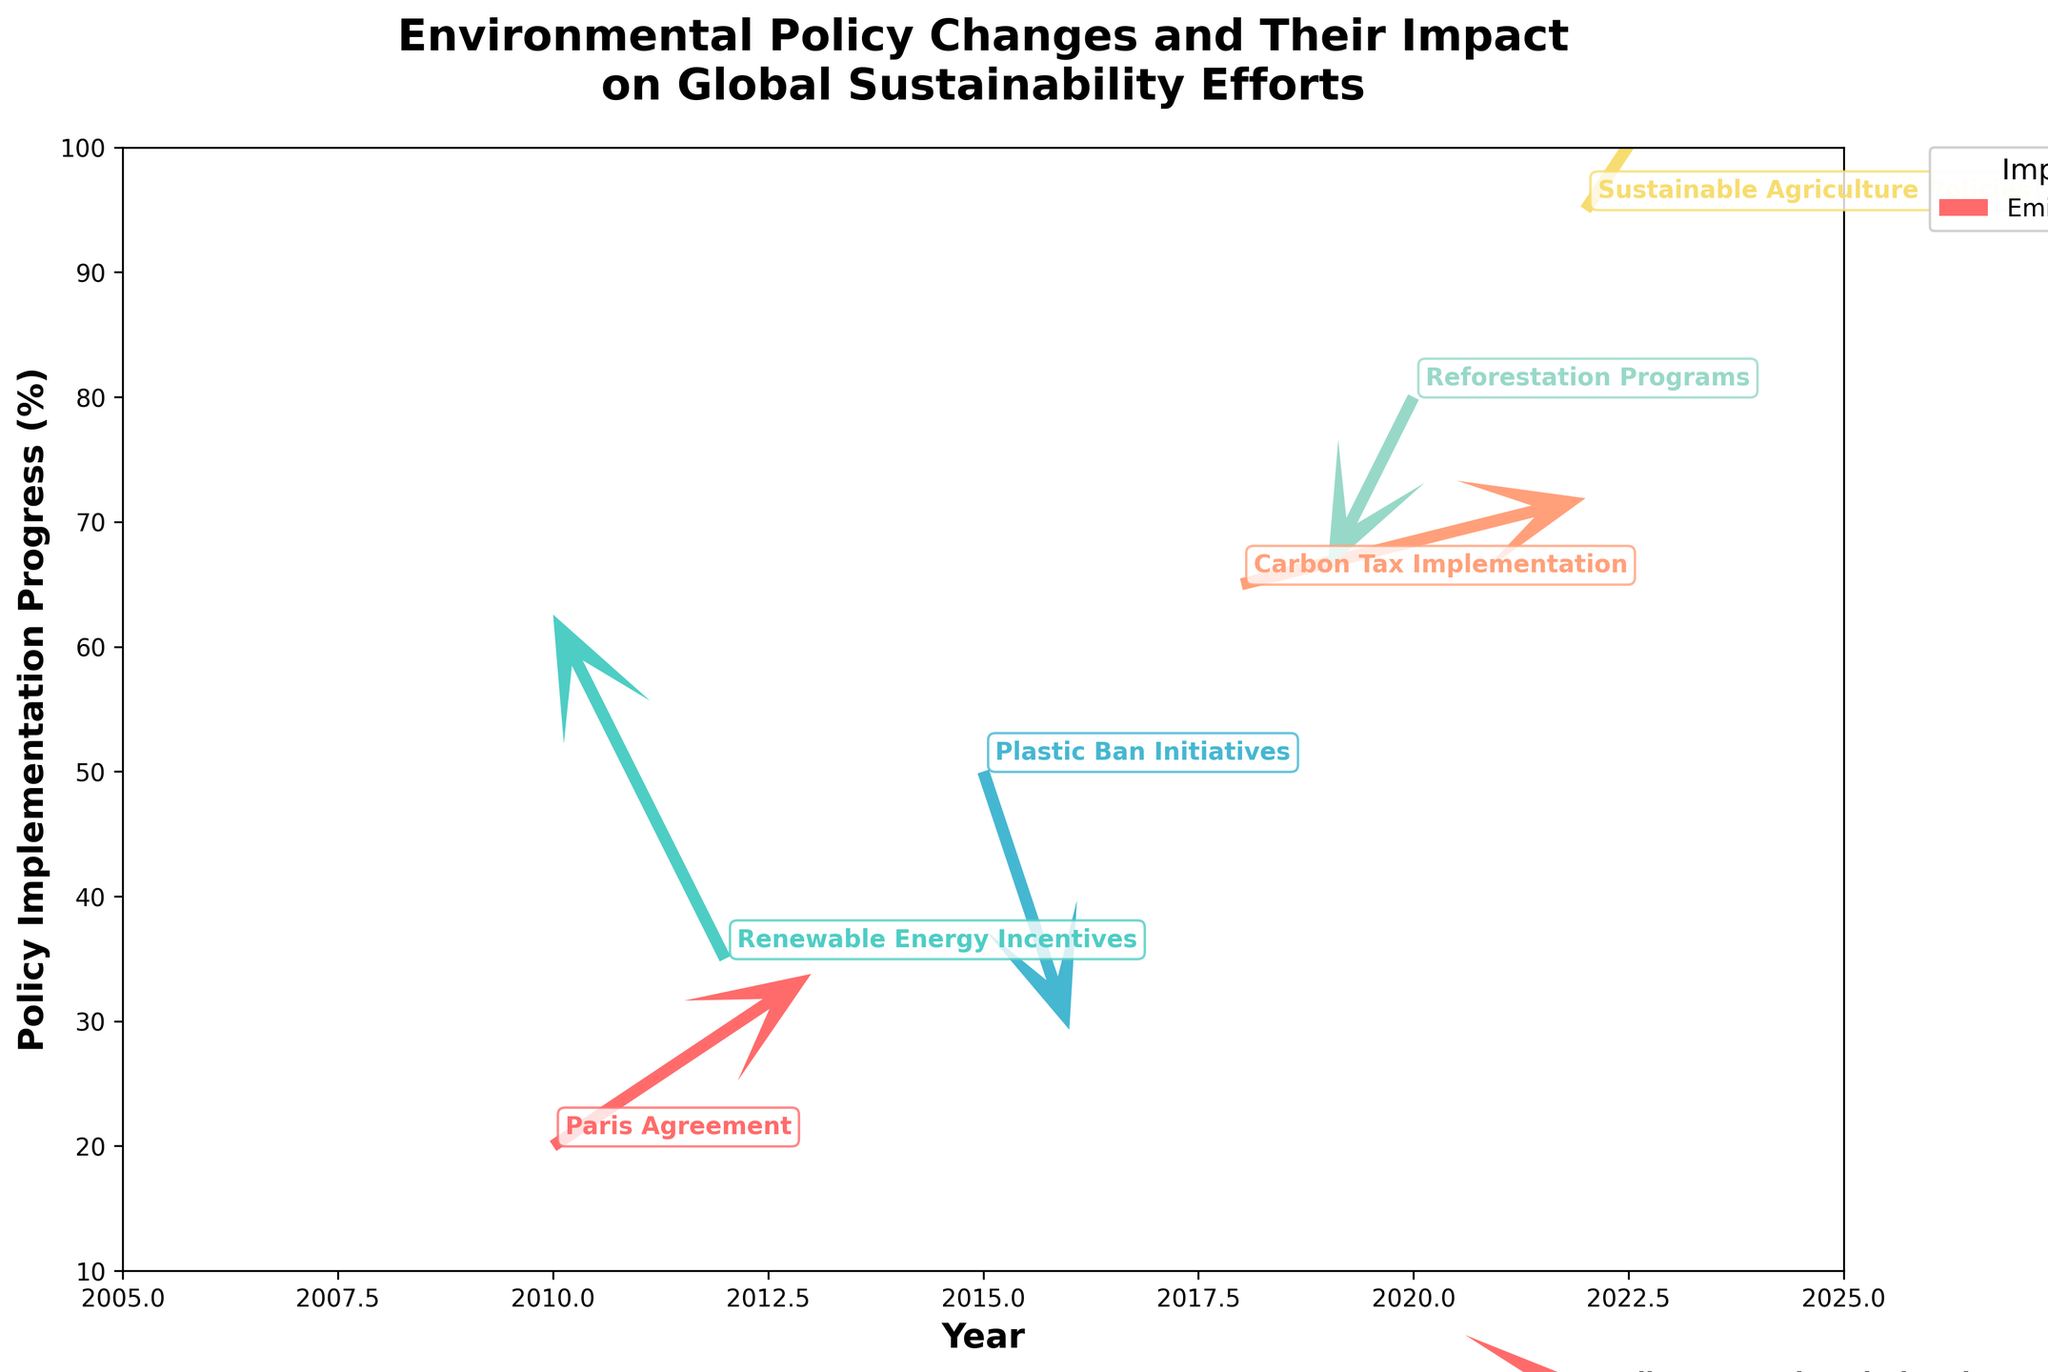What is the title of the figure? The title is usually presented at the top of the figure. It is written in large, bold text to summarize the visualized data.
Answer: Environmental Policy Changes and Their Impact on Global Sustainability Efforts Between which years are the policy implementations shown? The x-axis represents the years. By examining the x-axis, we see that policy implementations span from 2010 to 2022.
Answer: 2010 to 2022 Which colors represent the policies in the quiver plot? Each quiver and policy label is colored differently. Some visible colors include shades of red, green, blue, salmon, teal, and yellow.
Answer: Red, green, blue, salmon, teal, and yellow What impact does the “Paris Agreement” policy have? “Paris Agreement” is labeled next to a quiver whose label we need to read. It shows “Emissions Reduction” as its impact.
Answer: Emissions Reduction Which policy shows a great movement towards clean energy adoption? By identifying the policy associated with the arrow indicating "Clean Energy Adoption", we see it correlates with "Renewable Energy Incentives".
Answer: Renewable Energy Incentives How many policies target environmental impact areas? Each labeled policy in the quiver plot represents an environmental impact area; counting these labels gives us six.
Answer: Six Which policy had the largest positive change in y-direction (vertical progress)? Examining the y-components (V), the "Renewable Energy Incentives" policy has the largest positive value of 4.
Answer: Renewable Energy Incentives Where do we see the largest movement towards the reduction in ocean pollution? The policy labeled "Plastic Ban Initiatives" in the quiver plot points downward (negative y) indicating its effect on reducing ocean pollution.
Answer: Plastic Ban Initiatives How does the Carbon Tax Implementation move over time? The arrow representing "Carbon Tax Implementation" shows movement to the right (positive x) and slightly upwards, indicating positive progress in emissions control.
Answer: Right and slightly upwards Which policy indicated the smallest y-direction movement while advancing in a positive horizontal direction? By examining the y-components, "Sustainable Agriculture Policies" has a smaller positive vertical move (V=3), while moving positively in the x direction (U=2), smaller than Carbon Tax Implementation.
Answer: Sustainable Agriculture Policies 